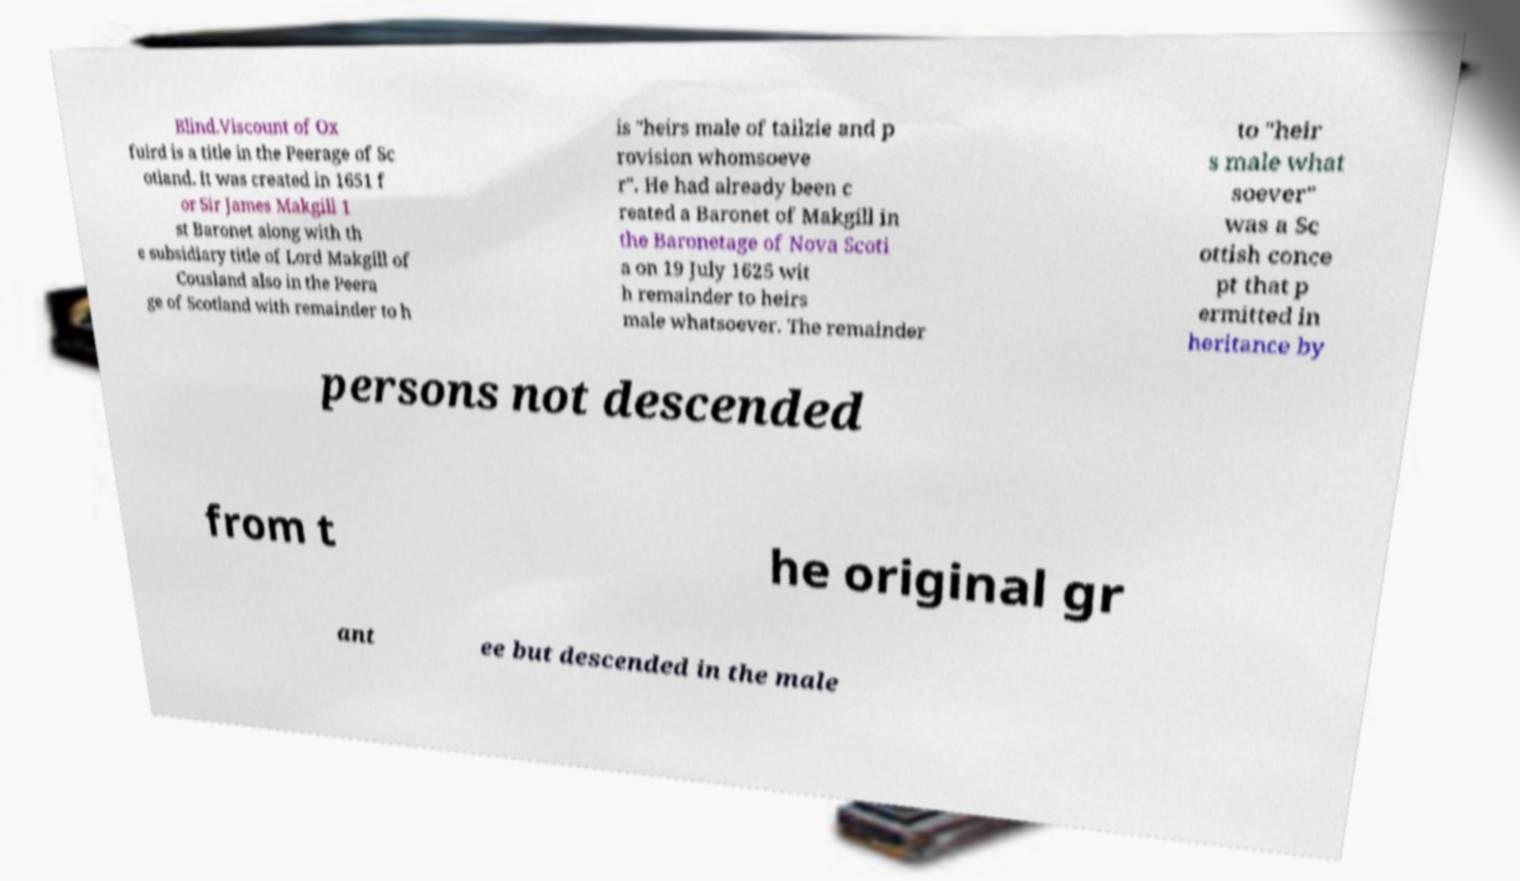Can you accurately transcribe the text from the provided image for me? Blind.Viscount of Ox fuird is a title in the Peerage of Sc otland. It was created in 1651 f or Sir James Makgill 1 st Baronet along with th e subsidiary title of Lord Makgill of Cousland also in the Peera ge of Scotland with remainder to h is "heirs male of tailzie and p rovision whomsoeve r". He had already been c reated a Baronet of Makgill in the Baronetage of Nova Scoti a on 19 July 1625 wit h remainder to heirs male whatsoever. The remainder to "heir s male what soever" was a Sc ottish conce pt that p ermitted in heritance by persons not descended from t he original gr ant ee but descended in the male 